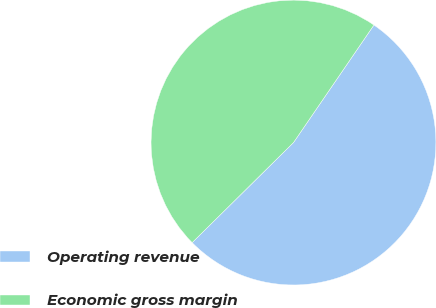<chart> <loc_0><loc_0><loc_500><loc_500><pie_chart><fcel>Operating revenue<fcel>Economic gross margin<nl><fcel>53.05%<fcel>46.95%<nl></chart> 